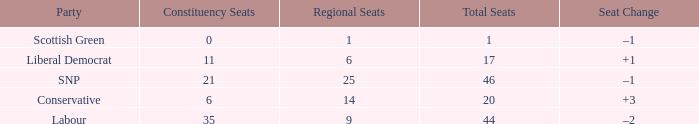What is the full number of Total Seats with a constituency seat number bigger than 0 with the Liberal Democrat party, and the Regional seat number is smaller than 6? None. 